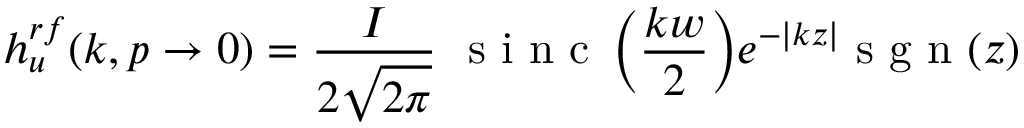Convert formula to latex. <formula><loc_0><loc_0><loc_500><loc_500>{ h } _ { u } ^ { r f } ( k , p \rightarrow 0 ) = \frac { I } { 2 \sqrt { 2 \pi } } { \sin c \left ( \frac { k w } { 2 } \right ) } e ^ { - \left | k z \right | } s g n ( z )</formula> 